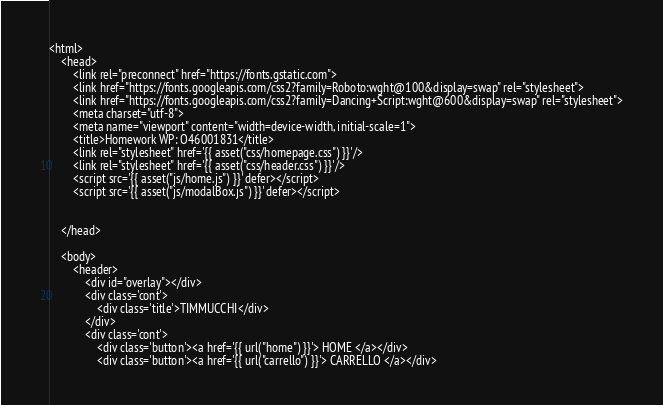<code> <loc_0><loc_0><loc_500><loc_500><_PHP_><html>
    <head>
        <link rel="preconnect" href="https://fonts.gstatic.com">
        <link href="https://fonts.googleapis.com/css2?family=Roboto:wght@100&display=swap" rel="stylesheet">
        <link href="https://fonts.googleapis.com/css2?family=Dancing+Script:wght@600&display=swap" rel="stylesheet">
        <meta charset="utf-8">
        <meta name="viewport" content="width=device-width, initial-scale=1">
        <title>Homework WP: O46001831</title>
        <link rel="stylesheet" href='{{ asset("css/homepage.css") }}'/>
        <link rel="stylesheet" href='{{ asset("css/header.css") }}'/>
        <script src='{{ asset("js/home.js") }}' defer></script>      
        <script src='{{ asset("js/modalBox.js") }}' defer></script>
                
         
    </head>

    <body>        
        <header>    
            <div id="overlay"></div>
            <div class='cont'>
                <div class='title'>TIMMUCCHI</div>
            </div>
            <div class='cont'>                
                <div class='button'><a href='{{ url("home") }}'> HOME </a></div>
                <div class='button'><a href='{{ url("carrello") }}'> CARRELLO </a></div></code> 